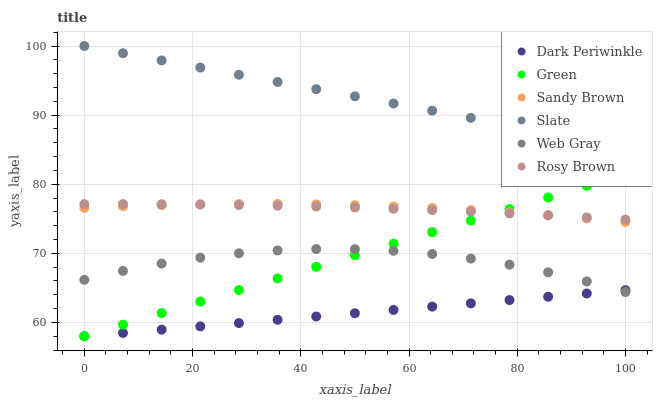Does Dark Periwinkle have the minimum area under the curve?
Answer yes or no. Yes. Does Slate have the maximum area under the curve?
Answer yes or no. Yes. Does Rosy Brown have the minimum area under the curve?
Answer yes or no. No. Does Rosy Brown have the maximum area under the curve?
Answer yes or no. No. Is Dark Periwinkle the smoothest?
Answer yes or no. Yes. Is Web Gray the roughest?
Answer yes or no. Yes. Is Slate the smoothest?
Answer yes or no. No. Is Slate the roughest?
Answer yes or no. No. Does Green have the lowest value?
Answer yes or no. Yes. Does Rosy Brown have the lowest value?
Answer yes or no. No. Does Slate have the highest value?
Answer yes or no. Yes. Does Rosy Brown have the highest value?
Answer yes or no. No. Is Dark Periwinkle less than Slate?
Answer yes or no. Yes. Is Sandy Brown greater than Web Gray?
Answer yes or no. Yes. Does Rosy Brown intersect Sandy Brown?
Answer yes or no. Yes. Is Rosy Brown less than Sandy Brown?
Answer yes or no. No. Is Rosy Brown greater than Sandy Brown?
Answer yes or no. No. Does Dark Periwinkle intersect Slate?
Answer yes or no. No. 